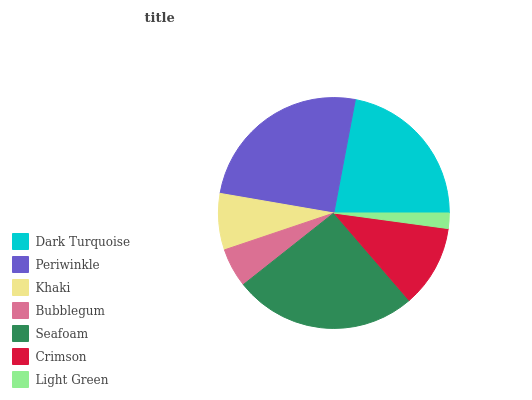Is Light Green the minimum?
Answer yes or no. Yes. Is Seafoam the maximum?
Answer yes or no. Yes. Is Periwinkle the minimum?
Answer yes or no. No. Is Periwinkle the maximum?
Answer yes or no. No. Is Periwinkle greater than Dark Turquoise?
Answer yes or no. Yes. Is Dark Turquoise less than Periwinkle?
Answer yes or no. Yes. Is Dark Turquoise greater than Periwinkle?
Answer yes or no. No. Is Periwinkle less than Dark Turquoise?
Answer yes or no. No. Is Crimson the high median?
Answer yes or no. Yes. Is Crimson the low median?
Answer yes or no. Yes. Is Light Green the high median?
Answer yes or no. No. Is Periwinkle the low median?
Answer yes or no. No. 